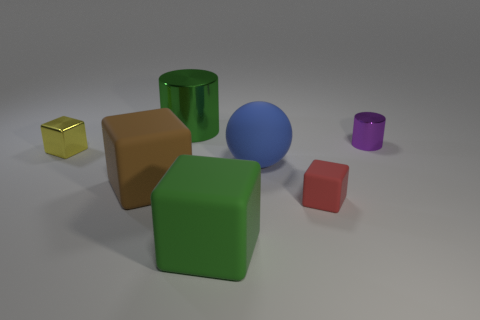There is a large metal thing; what shape is it?
Your answer should be very brief. Cylinder. How many other objects are there of the same material as the big cylinder?
Keep it short and to the point. 2. What is the color of the big thing that is to the left of the object behind the purple object that is to the right of the large green matte object?
Your answer should be very brief. Brown. What is the material of the other cube that is the same size as the brown block?
Provide a succinct answer. Rubber. What number of things are small metal objects that are right of the large metallic object or large yellow rubber cylinders?
Make the answer very short. 1. Is there a tiny metal block?
Give a very brief answer. Yes. There is a thing that is behind the purple metallic thing; what is it made of?
Give a very brief answer. Metal. There is a object that is the same color as the big cylinder; what material is it?
Provide a short and direct response. Rubber. What number of small objects are yellow metallic objects or yellow balls?
Offer a very short reply. 1. What is the color of the big rubber ball?
Make the answer very short. Blue. 